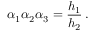Convert formula to latex. <formula><loc_0><loc_0><loc_500><loc_500>\alpha _ { 1 } \alpha _ { 2 } \alpha _ { 3 } = \frac { h _ { 1 } } { h _ { 2 } } \, .</formula> 